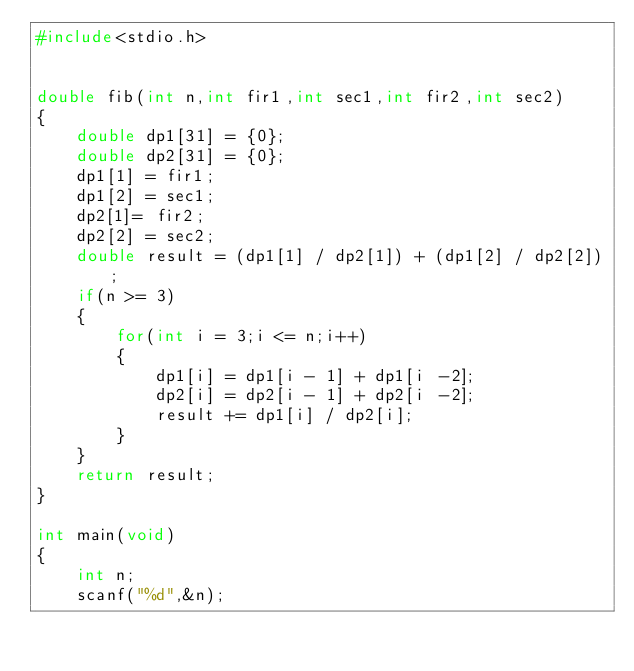Convert code to text. <code><loc_0><loc_0><loc_500><loc_500><_C_>#include<stdio.h>


double fib(int n,int fir1,int sec1,int fir2,int sec2)
{
		double dp1[31] = {0};
		double dp2[31] = {0};
		dp1[1] = fir1;
		dp1[2] = sec1;
		dp2[1]= fir2;
		dp2[2] = sec2;
		double result = (dp1[1] / dp2[1]) + (dp1[2] / dp2[2]);
		if(n >= 3)
		{
				for(int i = 3;i <= n;i++)
				{
						dp1[i] = dp1[i - 1] + dp1[i -2];
						dp2[i] = dp2[i - 1] + dp2[i -2];
						result += dp1[i] / dp2[i];
				}
		}
		return result;
}

int main(void)
{
		int n;
		scanf("%d",&n);</code> 